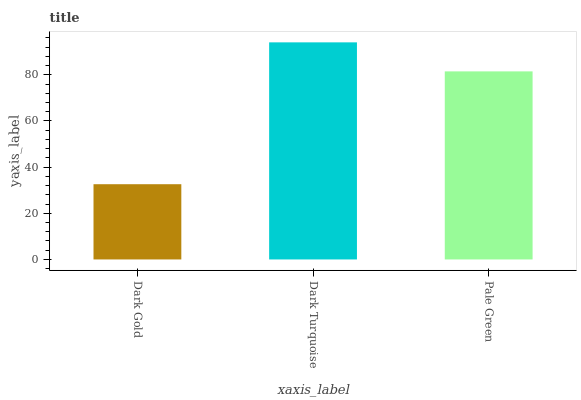Is Dark Gold the minimum?
Answer yes or no. Yes. Is Dark Turquoise the maximum?
Answer yes or no. Yes. Is Pale Green the minimum?
Answer yes or no. No. Is Pale Green the maximum?
Answer yes or no. No. Is Dark Turquoise greater than Pale Green?
Answer yes or no. Yes. Is Pale Green less than Dark Turquoise?
Answer yes or no. Yes. Is Pale Green greater than Dark Turquoise?
Answer yes or no. No. Is Dark Turquoise less than Pale Green?
Answer yes or no. No. Is Pale Green the high median?
Answer yes or no. Yes. Is Pale Green the low median?
Answer yes or no. Yes. Is Dark Turquoise the high median?
Answer yes or no. No. Is Dark Turquoise the low median?
Answer yes or no. No. 